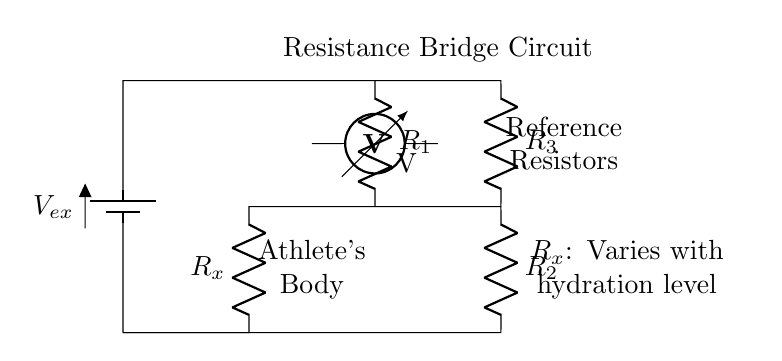What is the purpose of R_x in the circuit? R_x represents the variable resistance that changes with the hydration level of the athlete's body. This is crucial for measuring hydration since as hydration changes, the resistance alters, affecting the voltage output.
Answer: Varies with hydration level What component measures voltage in this circuit? The voltmeter is the component that measures voltage across the circuit. It is positioned between two points to indicate the potential difference.
Answer: Voltmeter What happens to the output voltage as hydration increases? As hydration increases, the resistance R_x decreases, leading to a change in the voltage measured across the voltmeter, which indicates the hydration level. Lower resistance generally means higher output voltage in this configuration.
Answer: Output voltage increases What is the role of the reference resistors in this circuit? The reference resistors provide a stable base for comparison against the variable resistance R_x, allowing for accurate measurement of changes in hydration by comparing voltages.
Answer: Establish baseline measurement How many resistors are used in this resistance bridge circuit? There are four resistors identified: R1, R2, R3, and R_x.
Answer: Four resistors What is the function of the battery in the circuit? The battery provides the required voltage (V_ex) necessary to drive the current through the circuit, enabling the measurement of resistance changes based on hydration levels.
Answer: Supplies voltage 